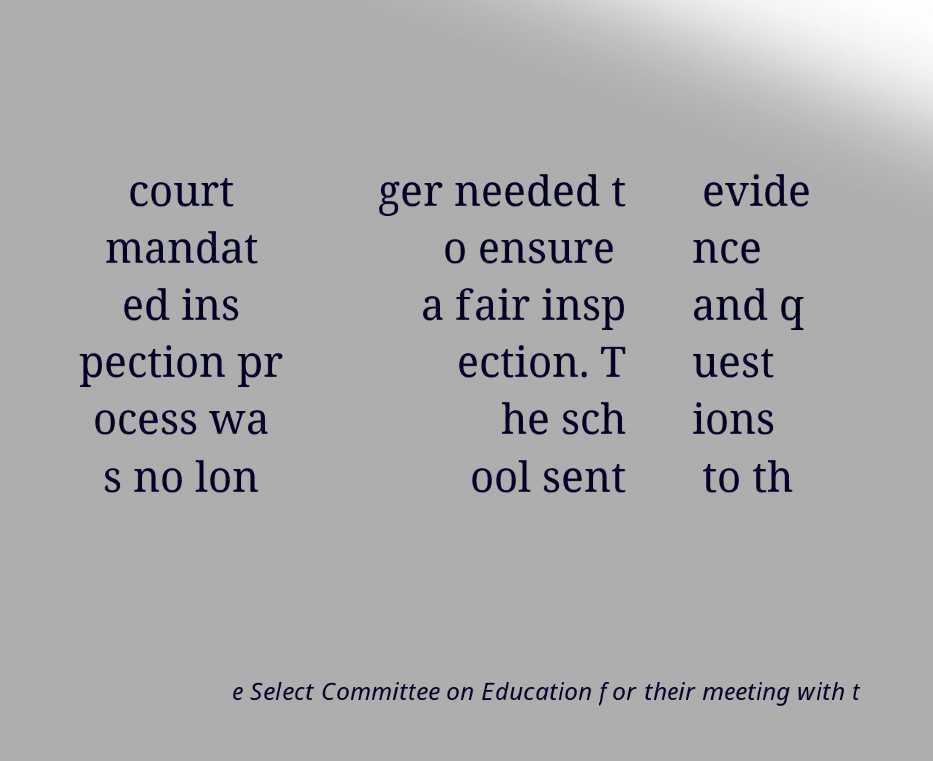I need the written content from this picture converted into text. Can you do that? court mandat ed ins pection pr ocess wa s no lon ger needed t o ensure a fair insp ection. T he sch ool sent evide nce and q uest ions to th e Select Committee on Education for their meeting with t 